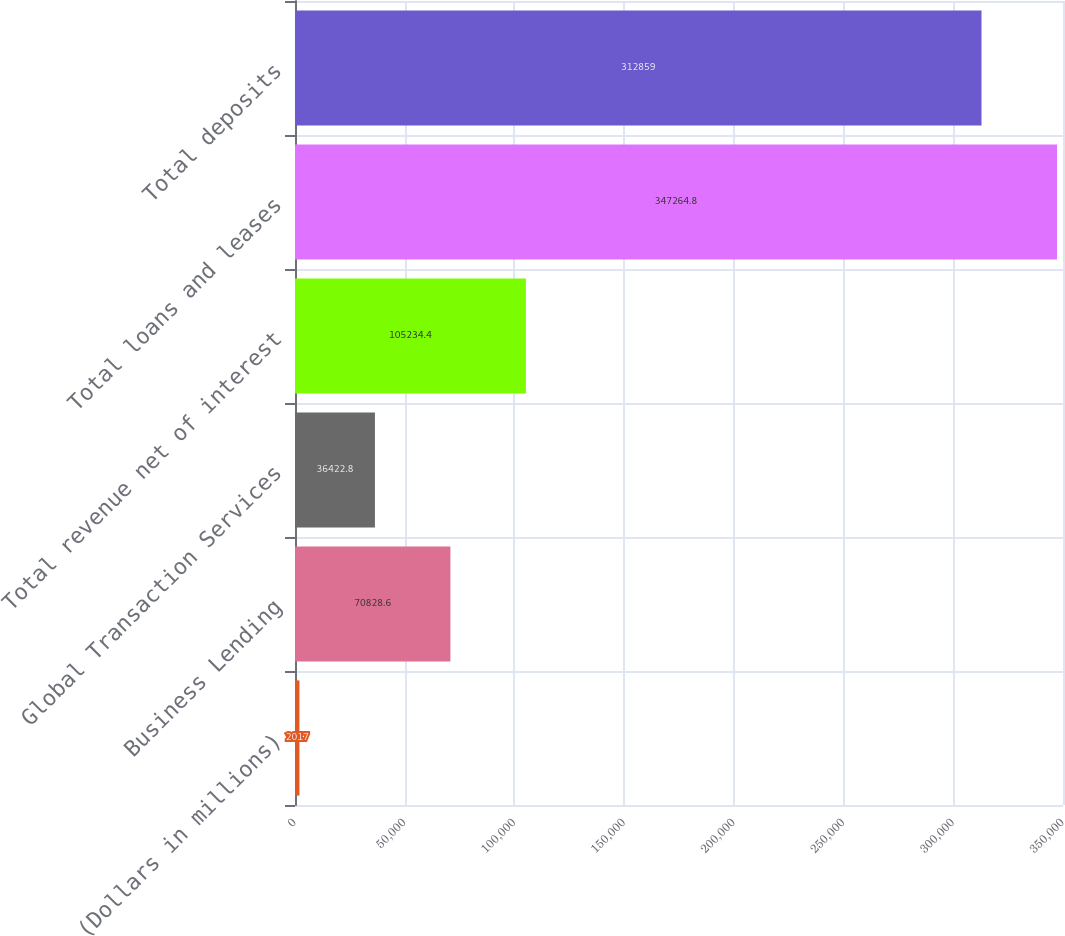Convert chart. <chart><loc_0><loc_0><loc_500><loc_500><bar_chart><fcel>(Dollars in millions)<fcel>Business Lending<fcel>Global Transaction Services<fcel>Total revenue net of interest<fcel>Total loans and leases<fcel>Total deposits<nl><fcel>2017<fcel>70828.6<fcel>36422.8<fcel>105234<fcel>347265<fcel>312859<nl></chart> 